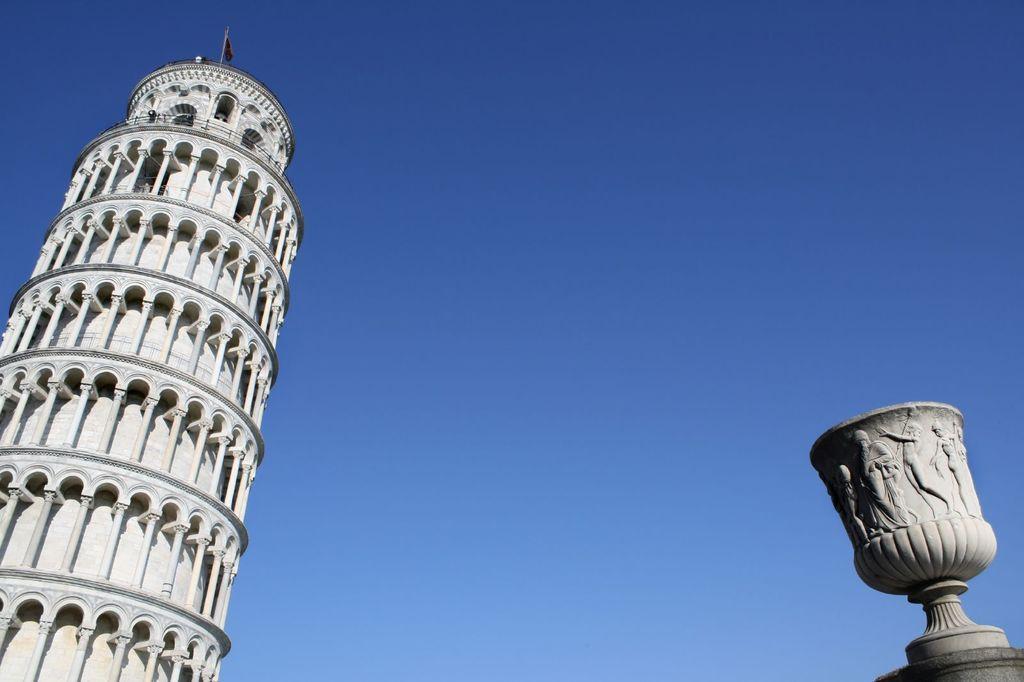In one or two sentences, can you explain what this image depicts? In this image there is a leaning tower of pizza on the left side. At the top there is the sky. On the right side there is a cement cup on which there are some engravings. 